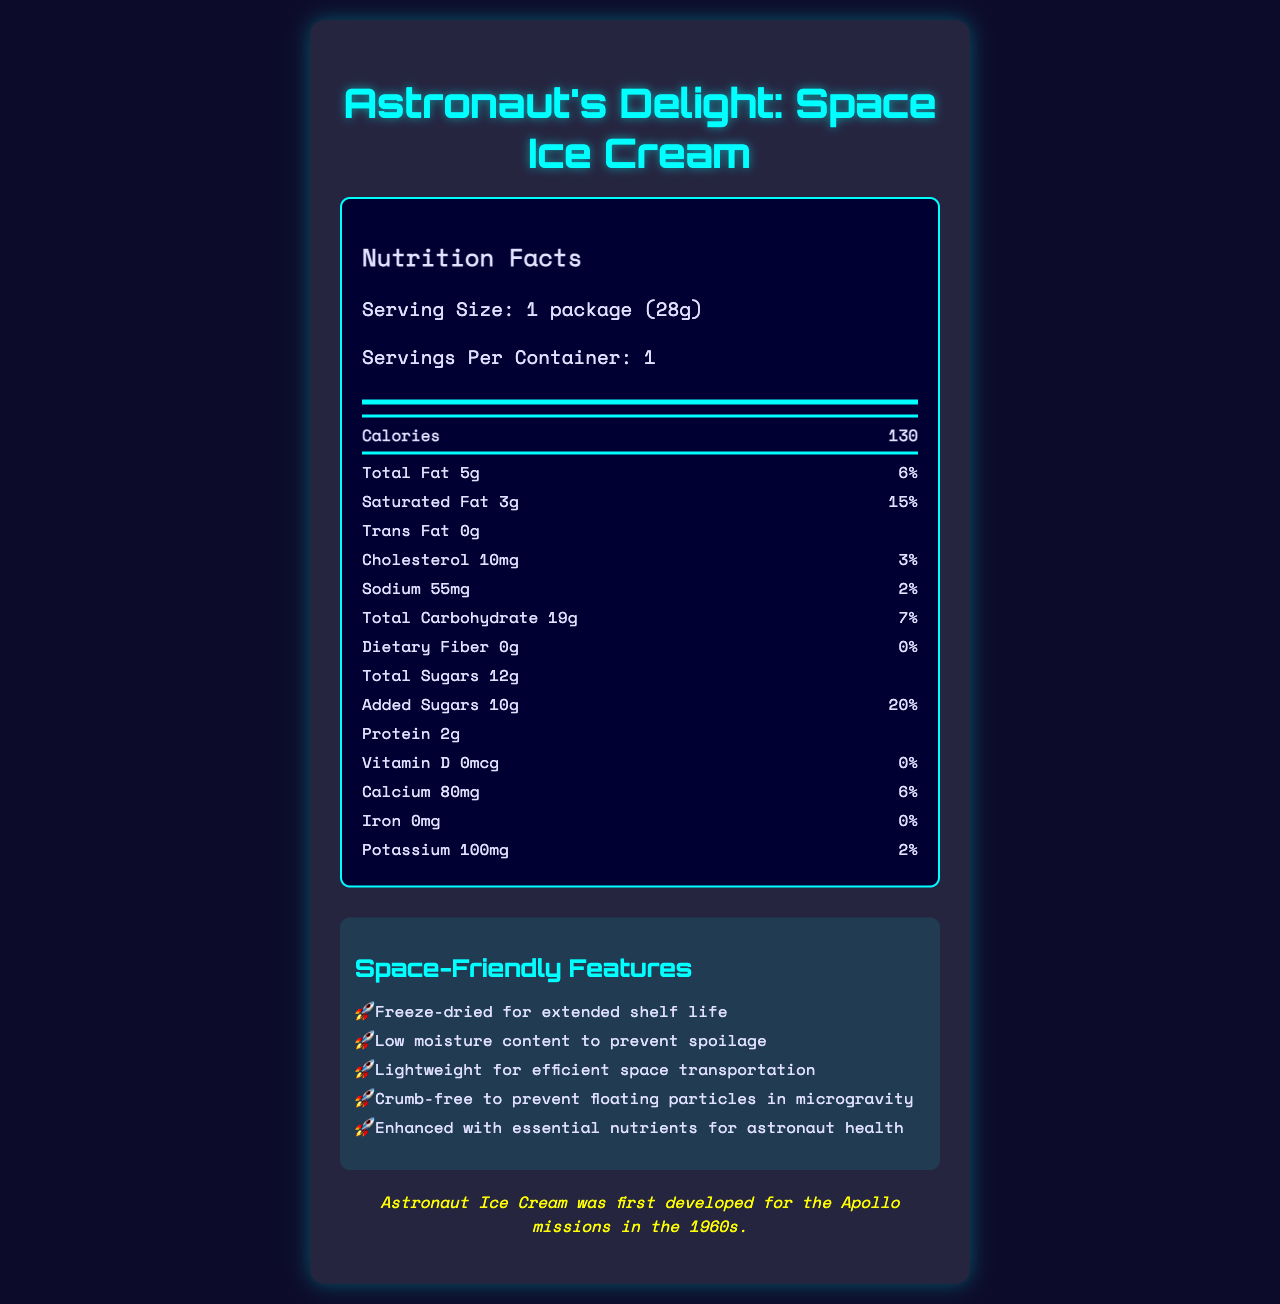what is the serving size for Astronaut's Delight: Space Ice Cream? The document specifies that the serving size is 1 package, which weighs 28 grams.
Answer: 1 package (28g) how many calories are in one serving? The nutrition label in the document lists the calories per serving as 130.
Answer: 130 calories what is the total fat content per serving? The document lists the total fat content as 5g per serving.
Answer: 5g what percentage of the daily value is saturated fat per serving? The document specifies that the percentage of the daily value for saturated fat per serving is 15%.
Answer: 15% what are the ingredients of Astronaut's Delight: Space Ice Cream? The ingredients are listed directly in the document.
Answer: Milk, Cream, Sugar, Corn Syrup, Whey, Cocoa (processed with alkali), Mono and Diglycerides, Guar Gum, Carrageenan, Artificial Flavor what feature makes Astronaut's Delight: Space Ice Cream lightweight for space transportation? The document mentions that the ice cream is freeze-dried, which makes it lightweight and suitable for space transport.
Answer: Freeze-dried for extended shelf life how much calcium is in one serving? The document provides the calcium content per serving as 80mg.
Answer: 80mg is refrigeration required for storing Astronaut's Delight: Space Ice Cream? The document states that no refrigeration is required and it should be stored in a cool, dry place.
Answer: No how much protein does one serving contain? A. 0g B. 1g C. 2g D. 3g The nutrition label in the document indicates that one serving contains 2 grams of protein.
Answer: C. 2g which of the following is not an allergen in the ice cream? 1. Milk 2. Sugar 3. Corn Syrup The document lists milk as an allergen, but not sugar or corn syrup.
Answer: 2. Sugar is freeze-drying used to prevent spoilage? One of the space-friendly features listed in the document is that the ice cream is freeze-dried to prevent spoilage.
Answer: Yes has Astronaut's Delight: Space Ice Cream been tested on any space missions? The document states it was mission-tested during the International Space Station Expedition 64.
Answer: Yes describe the main features and nutritional information of Astronaut's Delight: Space Ice Cream. This question requires summarizing both the nutritional facts and the special features highlighted in the document, summarizing the product as space-friendly and nutritionally detailed.
Answer: Astronaut's Delight: Space Ice Cream is a freeze-dried treat designed for space with a serving size of 1 package (28g) containing 130 calories, 5g of total fat, 3g of saturated fat, 0g of trans fat, 10mg of cholesterol, 55mg of sodium, 19g of carbohydrates, 0g of dietary fiber, 12g of sugars (including 10g of added sugars), and 2g of protein. It is designed with space-friendly features such as extended shelf life, low moisture content, lightweight, and crumb-free properties. how much sodium does the ice cream contain? The document lists the sodium content as 55mg per serving.
Answer: 55mg what year was astronaut ice cream first developed for the Apollo missions? The document includes a fun fact stating that astronaut ice cream was first developed for the Apollo missions in the 1960s.
Answer: 1960s what is the daily value percentage for iron per serving? The document specifies that the daily value percentage for iron per serving is 0%.
Answer: 0% are there any rehydration instructions for the ice cream? The document states that no rehydration is required and it can be enjoyed straight from the package.
Answer: No how much potassium is present in one serving? The document lists the potassium content as 100mg per serving.
Answer: 100mg which essential nutrients are enhanced for astronaut health in this ice cream? The document mentions that the ice cream is enhanced with essential nutrients for astronaut health but does not specify which nutrients are enhanced.
Answer: Cannot be determined 